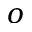<formula> <loc_0><loc_0><loc_500><loc_500>o</formula> 